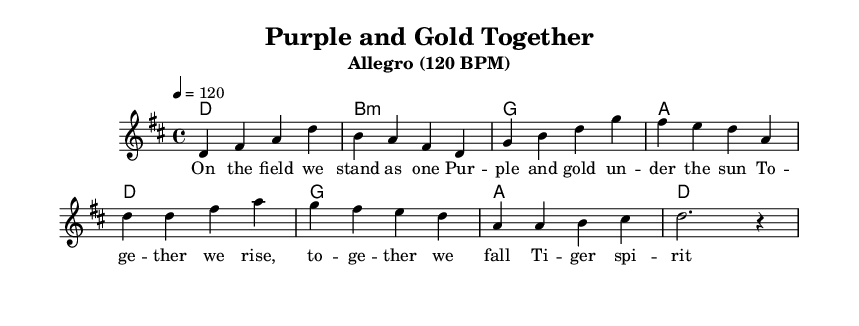what is the key signature of this music? The key signature is indicated by the sharps or flats shown at the beginning of the staff. Here, it shows two sharps (F# and C#), identifying the piece as D major.
Answer: D major what is the time signature of this music? The time signature appears at the beginning of the staff and shows 4 over 4, meaning there are four beats in each measure and the quarter note gets one beat.
Answer: 4/4 what is the tempo of this music? The tempo indication is found typically at the beginning with the term "Allegro" followed by a BPM marking. It states 4 equals 120, which indicates a speed of 120 beats per minute.
Answer: 120 BPM how many measures are in the verse? To determine the number of measures in the verse, we count each group of beats separated by vertical lines (bars). The verse has four measures as indicated by the structure provided.
Answer: 4 measures what are the themes of the lyrics? The lyrics emphasize unity and togetherness, highlighting camaraderie on the field, and a strong spirit that unites the team. This can be inferred from phrases that connect the idea of strength in numbers and spirit.
Answer: Teamwork and camaraderie which chord is played in the last measure of the chorus? To find the chord in the last measure of the chorus, we look directly at the chord symbols indicated above the staff. The last measure of the chorus has a 'd' chord written above it.
Answer: d how does this piece reflect Rhythm and Blues characteristics? This piece reflects Rhythm and Blues through its use of a strong backbeat, the soulful nature of the melody, and thematic elements that reflect community and togetherness, prominent in many R&B songs.
Answer: Strong backbeat and soulful melody 